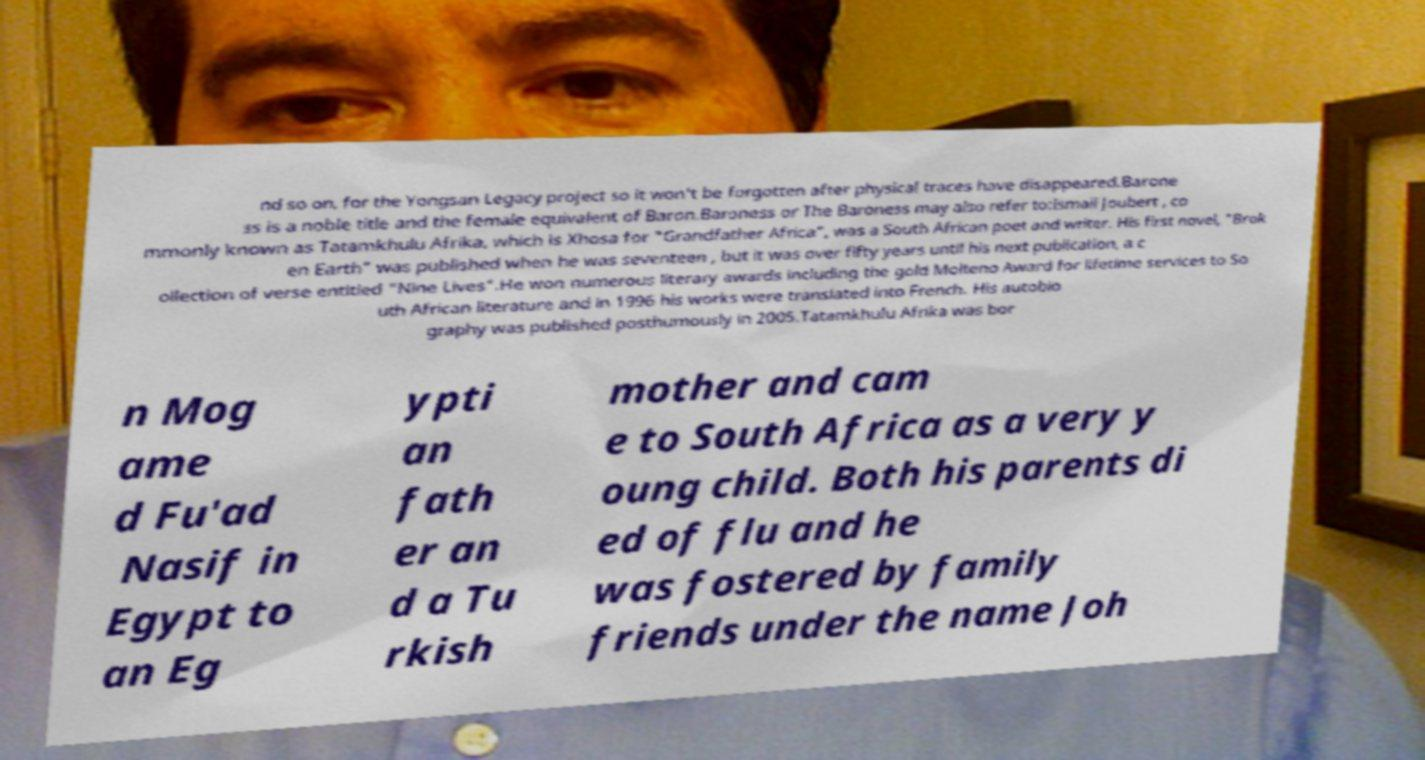Can you read and provide the text displayed in the image?This photo seems to have some interesting text. Can you extract and type it out for me? nd so on, for the Yongsan Legacy project so it won't be forgotten after physical traces have disappeared.Barone ss is a noble title and the female equivalent of Baron.Baroness or The Baroness may also refer to:Ismail Joubert , co mmonly known as Tatamkhulu Afrika, which is Xhosa for "Grandfather Africa", was a South African poet and writer. His first novel, "Brok en Earth" was published when he was seventeen , but it was over fifty years until his next publication, a c ollection of verse entitled "Nine Lives".He won numerous literary awards including the gold Molteno Award for lifetime services to So uth African literature and in 1996 his works were translated into French. His autobio graphy was published posthumously in 2005.Tatamkhulu Afrika was bor n Mog ame d Fu'ad Nasif in Egypt to an Eg ypti an fath er an d a Tu rkish mother and cam e to South Africa as a very y oung child. Both his parents di ed of flu and he was fostered by family friends under the name Joh 